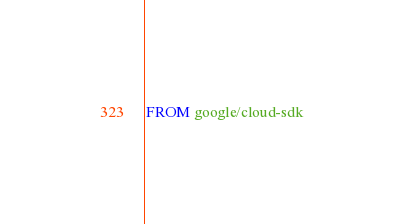Convert code to text. <code><loc_0><loc_0><loc_500><loc_500><_Dockerfile_>FROM google/cloud-sdk

</code> 